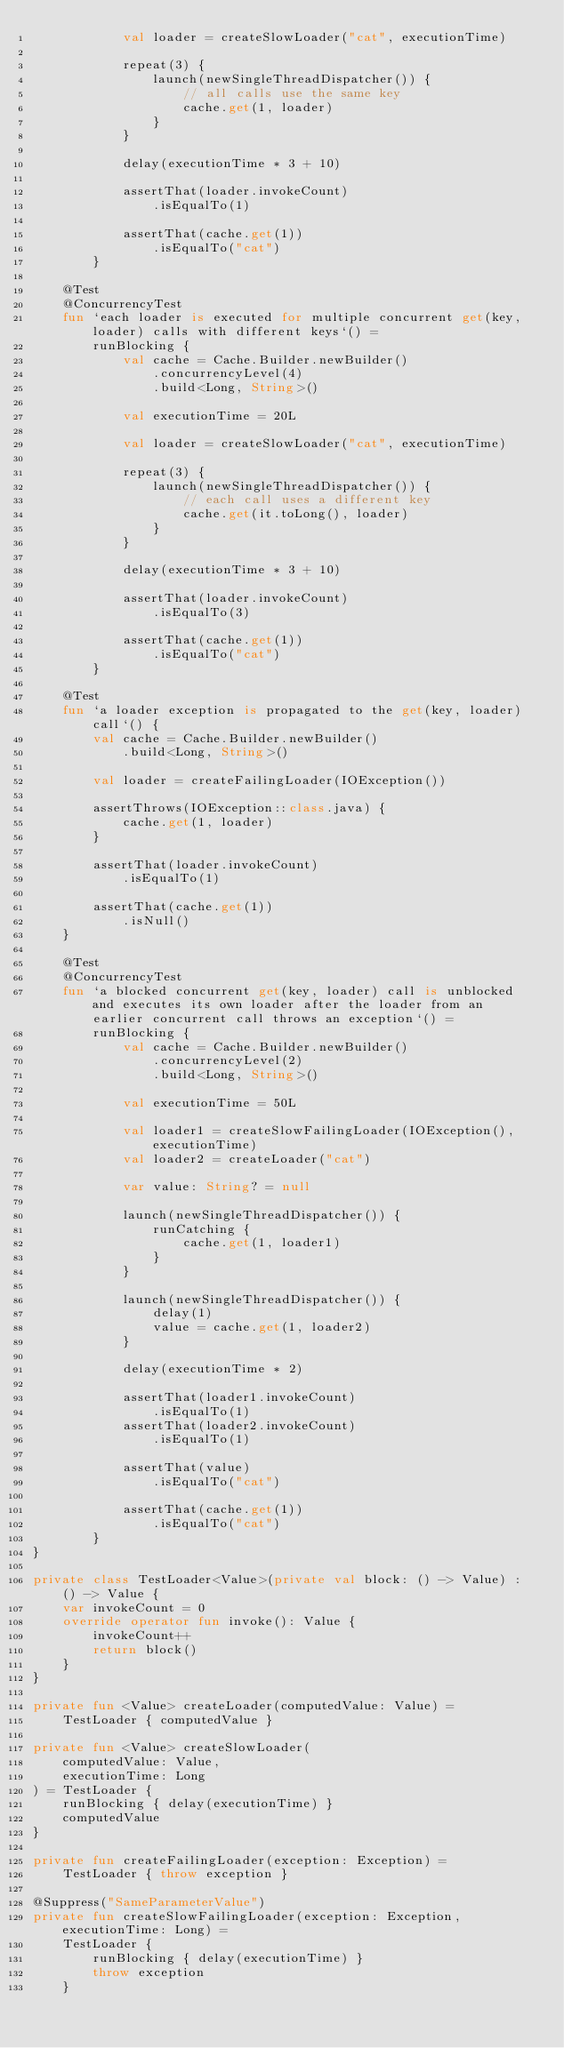Convert code to text. <code><loc_0><loc_0><loc_500><loc_500><_Kotlin_>            val loader = createSlowLoader("cat", executionTime)

            repeat(3) {
                launch(newSingleThreadDispatcher()) {
                    // all calls use the same key
                    cache.get(1, loader)
                }
            }

            delay(executionTime * 3 + 10)

            assertThat(loader.invokeCount)
                .isEqualTo(1)

            assertThat(cache.get(1))
                .isEqualTo("cat")
        }

    @Test
    @ConcurrencyTest
    fun `each loader is executed for multiple concurrent get(key, loader) calls with different keys`() =
        runBlocking {
            val cache = Cache.Builder.newBuilder()
                .concurrencyLevel(4)
                .build<Long, String>()

            val executionTime = 20L

            val loader = createSlowLoader("cat", executionTime)

            repeat(3) {
                launch(newSingleThreadDispatcher()) {
                    // each call uses a different key
                    cache.get(it.toLong(), loader)
                }
            }

            delay(executionTime * 3 + 10)

            assertThat(loader.invokeCount)
                .isEqualTo(3)

            assertThat(cache.get(1))
                .isEqualTo("cat")
        }

    @Test
    fun `a loader exception is propagated to the get(key, loader) call`() {
        val cache = Cache.Builder.newBuilder()
            .build<Long, String>()

        val loader = createFailingLoader(IOException())

        assertThrows(IOException::class.java) {
            cache.get(1, loader)
        }

        assertThat(loader.invokeCount)
            .isEqualTo(1)

        assertThat(cache.get(1))
            .isNull()
    }

    @Test
    @ConcurrencyTest
    fun `a blocked concurrent get(key, loader) call is unblocked and executes its own loader after the loader from an earlier concurrent call throws an exception`() =
        runBlocking {
            val cache = Cache.Builder.newBuilder()
                .concurrencyLevel(2)
                .build<Long, String>()

            val executionTime = 50L

            val loader1 = createSlowFailingLoader(IOException(), executionTime)
            val loader2 = createLoader("cat")

            var value: String? = null

            launch(newSingleThreadDispatcher()) {
                runCatching {
                    cache.get(1, loader1)
                }
            }

            launch(newSingleThreadDispatcher()) {
                delay(1)
                value = cache.get(1, loader2)
            }

            delay(executionTime * 2)

            assertThat(loader1.invokeCount)
                .isEqualTo(1)
            assertThat(loader2.invokeCount)
                .isEqualTo(1)

            assertThat(value)
                .isEqualTo("cat")

            assertThat(cache.get(1))
                .isEqualTo("cat")
        }
}

private class TestLoader<Value>(private val block: () -> Value) : () -> Value {
    var invokeCount = 0
    override operator fun invoke(): Value {
        invokeCount++
        return block()
    }
}

private fun <Value> createLoader(computedValue: Value) =
    TestLoader { computedValue }

private fun <Value> createSlowLoader(
    computedValue: Value,
    executionTime: Long
) = TestLoader {
    runBlocking { delay(executionTime) }
    computedValue
}

private fun createFailingLoader(exception: Exception) =
    TestLoader { throw exception }

@Suppress("SameParameterValue")
private fun createSlowFailingLoader(exception: Exception, executionTime: Long) =
    TestLoader {
        runBlocking { delay(executionTime) }
        throw exception
    }
</code> 